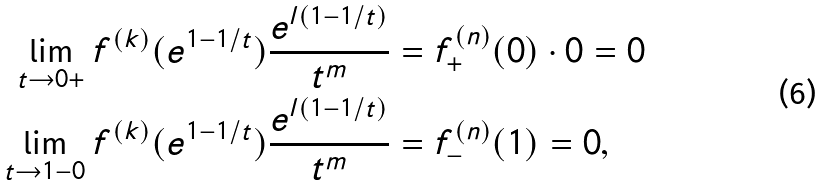<formula> <loc_0><loc_0><loc_500><loc_500>\lim _ { t \to 0 + } f ^ { ( k ) } ( e ^ { 1 - 1 / t } ) \frac { e ^ { l ( 1 - 1 / t ) } } { t ^ { m } } & = f _ { + } ^ { ( n ) } ( 0 ) \cdot 0 = 0 \\ \lim _ { t \to 1 - 0 } f ^ { ( k ) } ( e ^ { 1 - 1 / t } ) \frac { e ^ { l ( 1 - 1 / t ) } } { t ^ { m } } & = f _ { - } ^ { ( n ) } ( 1 ) = 0 ,</formula> 